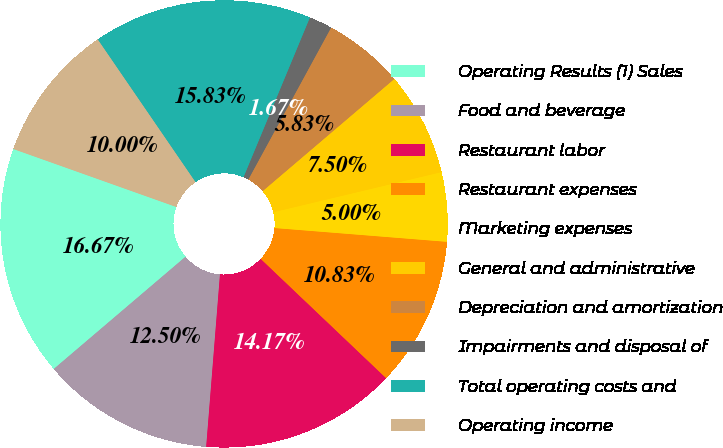Convert chart. <chart><loc_0><loc_0><loc_500><loc_500><pie_chart><fcel>Operating Results (1) Sales<fcel>Food and beverage<fcel>Restaurant labor<fcel>Restaurant expenses<fcel>Marketing expenses<fcel>General and administrative<fcel>Depreciation and amortization<fcel>Impairments and disposal of<fcel>Total operating costs and<fcel>Operating income<nl><fcel>16.67%<fcel>12.5%<fcel>14.17%<fcel>10.83%<fcel>5.0%<fcel>7.5%<fcel>5.83%<fcel>1.67%<fcel>15.83%<fcel>10.0%<nl></chart> 